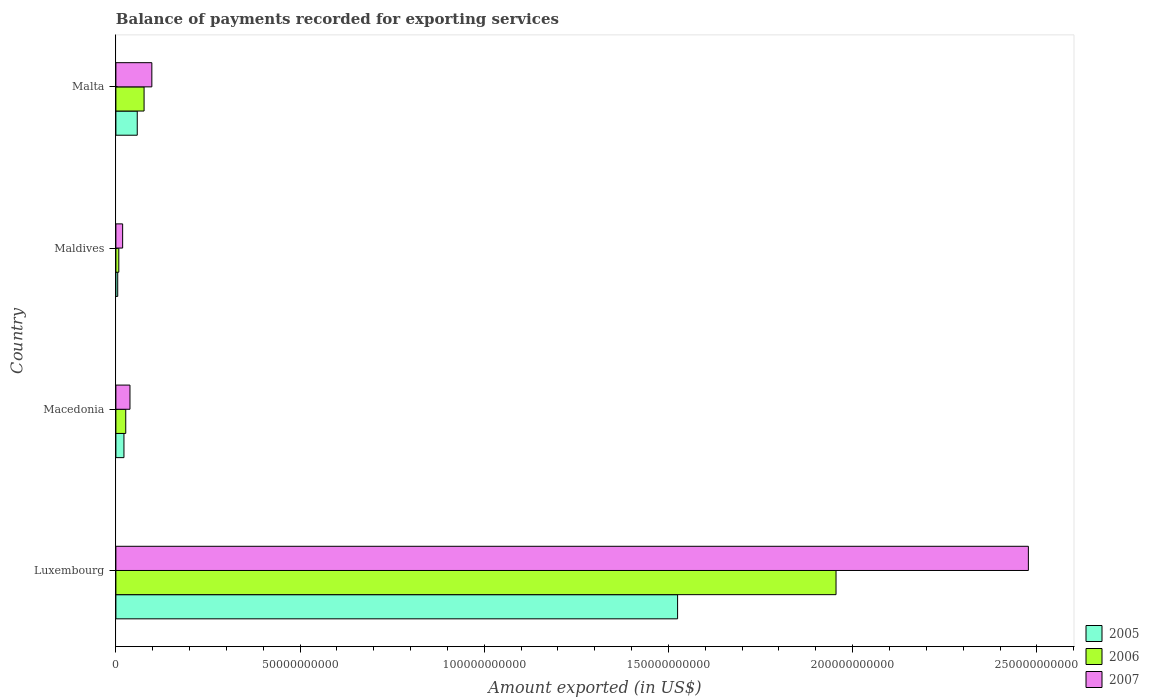How many different coloured bars are there?
Give a very brief answer. 3. How many groups of bars are there?
Offer a very short reply. 4. Are the number of bars per tick equal to the number of legend labels?
Make the answer very short. Yes. Are the number of bars on each tick of the Y-axis equal?
Your answer should be very brief. Yes. How many bars are there on the 4th tick from the bottom?
Give a very brief answer. 3. What is the label of the 4th group of bars from the top?
Your response must be concise. Luxembourg. In how many cases, is the number of bars for a given country not equal to the number of legend labels?
Give a very brief answer. 0. What is the amount exported in 2006 in Maldives?
Your response must be concise. 7.93e+08. Across all countries, what is the maximum amount exported in 2005?
Provide a succinct answer. 1.52e+11. Across all countries, what is the minimum amount exported in 2005?
Your answer should be very brief. 4.95e+08. In which country was the amount exported in 2006 maximum?
Keep it short and to the point. Luxembourg. In which country was the amount exported in 2006 minimum?
Keep it short and to the point. Maldives. What is the total amount exported in 2007 in the graph?
Ensure brevity in your answer.  2.63e+11. What is the difference between the amount exported in 2006 in Luxembourg and that in Maldives?
Provide a succinct answer. 1.95e+11. What is the difference between the amount exported in 2007 in Malta and the amount exported in 2005 in Maldives?
Offer a very short reply. 9.27e+09. What is the average amount exported in 2007 per country?
Offer a very short reply. 6.58e+1. What is the difference between the amount exported in 2006 and amount exported in 2007 in Maldives?
Keep it short and to the point. -1.04e+09. In how many countries, is the amount exported in 2005 greater than 20000000000 US$?
Offer a very short reply. 1. What is the ratio of the amount exported in 2006 in Luxembourg to that in Malta?
Keep it short and to the point. 25.55. What is the difference between the highest and the second highest amount exported in 2006?
Give a very brief answer. 1.88e+11. What is the difference between the highest and the lowest amount exported in 2007?
Give a very brief answer. 2.46e+11. In how many countries, is the amount exported in 2007 greater than the average amount exported in 2007 taken over all countries?
Make the answer very short. 1. What does the 3rd bar from the bottom in Maldives represents?
Your answer should be very brief. 2007. Are all the bars in the graph horizontal?
Your answer should be very brief. Yes. How many countries are there in the graph?
Your answer should be very brief. 4. Does the graph contain any zero values?
Your answer should be very brief. No. Where does the legend appear in the graph?
Provide a succinct answer. Bottom right. How many legend labels are there?
Provide a succinct answer. 3. What is the title of the graph?
Your answer should be very brief. Balance of payments recorded for exporting services. What is the label or title of the X-axis?
Make the answer very short. Amount exported (in US$). What is the Amount exported (in US$) in 2005 in Luxembourg?
Keep it short and to the point. 1.52e+11. What is the Amount exported (in US$) of 2006 in Luxembourg?
Provide a succinct answer. 1.95e+11. What is the Amount exported (in US$) in 2007 in Luxembourg?
Keep it short and to the point. 2.48e+11. What is the Amount exported (in US$) in 2005 in Macedonia?
Your response must be concise. 2.19e+09. What is the Amount exported (in US$) of 2006 in Macedonia?
Your answer should be compact. 2.68e+09. What is the Amount exported (in US$) in 2007 in Macedonia?
Give a very brief answer. 3.82e+09. What is the Amount exported (in US$) in 2005 in Maldives?
Your response must be concise. 4.95e+08. What is the Amount exported (in US$) in 2006 in Maldives?
Offer a terse response. 7.93e+08. What is the Amount exported (in US$) in 2007 in Maldives?
Offer a terse response. 1.83e+09. What is the Amount exported (in US$) in 2005 in Malta?
Give a very brief answer. 5.80e+09. What is the Amount exported (in US$) of 2006 in Malta?
Keep it short and to the point. 7.65e+09. What is the Amount exported (in US$) in 2007 in Malta?
Make the answer very short. 9.76e+09. Across all countries, what is the maximum Amount exported (in US$) in 2005?
Your response must be concise. 1.52e+11. Across all countries, what is the maximum Amount exported (in US$) of 2006?
Your answer should be compact. 1.95e+11. Across all countries, what is the maximum Amount exported (in US$) of 2007?
Your answer should be very brief. 2.48e+11. Across all countries, what is the minimum Amount exported (in US$) of 2005?
Offer a very short reply. 4.95e+08. Across all countries, what is the minimum Amount exported (in US$) of 2006?
Offer a very short reply. 7.93e+08. Across all countries, what is the minimum Amount exported (in US$) of 2007?
Provide a short and direct response. 1.83e+09. What is the total Amount exported (in US$) of 2005 in the graph?
Your answer should be very brief. 1.61e+11. What is the total Amount exported (in US$) of 2006 in the graph?
Offer a terse response. 2.07e+11. What is the total Amount exported (in US$) in 2007 in the graph?
Your answer should be very brief. 2.63e+11. What is the difference between the Amount exported (in US$) of 2005 in Luxembourg and that in Macedonia?
Ensure brevity in your answer.  1.50e+11. What is the difference between the Amount exported (in US$) of 2006 in Luxembourg and that in Macedonia?
Your answer should be compact. 1.93e+11. What is the difference between the Amount exported (in US$) of 2007 in Luxembourg and that in Macedonia?
Provide a short and direct response. 2.44e+11. What is the difference between the Amount exported (in US$) of 2005 in Luxembourg and that in Maldives?
Keep it short and to the point. 1.52e+11. What is the difference between the Amount exported (in US$) of 2006 in Luxembourg and that in Maldives?
Ensure brevity in your answer.  1.95e+11. What is the difference between the Amount exported (in US$) in 2007 in Luxembourg and that in Maldives?
Your response must be concise. 2.46e+11. What is the difference between the Amount exported (in US$) of 2005 in Luxembourg and that in Malta?
Ensure brevity in your answer.  1.47e+11. What is the difference between the Amount exported (in US$) of 2006 in Luxembourg and that in Malta?
Ensure brevity in your answer.  1.88e+11. What is the difference between the Amount exported (in US$) in 2007 in Luxembourg and that in Malta?
Offer a very short reply. 2.38e+11. What is the difference between the Amount exported (in US$) of 2005 in Macedonia and that in Maldives?
Provide a succinct answer. 1.69e+09. What is the difference between the Amount exported (in US$) of 2006 in Macedonia and that in Maldives?
Provide a short and direct response. 1.89e+09. What is the difference between the Amount exported (in US$) in 2007 in Macedonia and that in Maldives?
Your response must be concise. 1.99e+09. What is the difference between the Amount exported (in US$) of 2005 in Macedonia and that in Malta?
Offer a terse response. -3.61e+09. What is the difference between the Amount exported (in US$) in 2006 in Macedonia and that in Malta?
Offer a terse response. -4.97e+09. What is the difference between the Amount exported (in US$) of 2007 in Macedonia and that in Malta?
Your answer should be compact. -5.94e+09. What is the difference between the Amount exported (in US$) in 2005 in Maldives and that in Malta?
Offer a very short reply. -5.30e+09. What is the difference between the Amount exported (in US$) of 2006 in Maldives and that in Malta?
Offer a very short reply. -6.86e+09. What is the difference between the Amount exported (in US$) in 2007 in Maldives and that in Malta?
Ensure brevity in your answer.  -7.93e+09. What is the difference between the Amount exported (in US$) of 2005 in Luxembourg and the Amount exported (in US$) of 2006 in Macedonia?
Provide a short and direct response. 1.50e+11. What is the difference between the Amount exported (in US$) in 2005 in Luxembourg and the Amount exported (in US$) in 2007 in Macedonia?
Provide a succinct answer. 1.49e+11. What is the difference between the Amount exported (in US$) of 2006 in Luxembourg and the Amount exported (in US$) of 2007 in Macedonia?
Ensure brevity in your answer.  1.92e+11. What is the difference between the Amount exported (in US$) of 2005 in Luxembourg and the Amount exported (in US$) of 2006 in Maldives?
Offer a very short reply. 1.52e+11. What is the difference between the Amount exported (in US$) of 2005 in Luxembourg and the Amount exported (in US$) of 2007 in Maldives?
Offer a terse response. 1.51e+11. What is the difference between the Amount exported (in US$) in 2006 in Luxembourg and the Amount exported (in US$) in 2007 in Maldives?
Offer a terse response. 1.94e+11. What is the difference between the Amount exported (in US$) in 2005 in Luxembourg and the Amount exported (in US$) in 2006 in Malta?
Offer a terse response. 1.45e+11. What is the difference between the Amount exported (in US$) of 2005 in Luxembourg and the Amount exported (in US$) of 2007 in Malta?
Provide a short and direct response. 1.43e+11. What is the difference between the Amount exported (in US$) in 2006 in Luxembourg and the Amount exported (in US$) in 2007 in Malta?
Offer a very short reply. 1.86e+11. What is the difference between the Amount exported (in US$) in 2005 in Macedonia and the Amount exported (in US$) in 2006 in Maldives?
Provide a succinct answer. 1.40e+09. What is the difference between the Amount exported (in US$) of 2005 in Macedonia and the Amount exported (in US$) of 2007 in Maldives?
Ensure brevity in your answer.  3.59e+08. What is the difference between the Amount exported (in US$) of 2006 in Macedonia and the Amount exported (in US$) of 2007 in Maldives?
Provide a short and direct response. 8.48e+08. What is the difference between the Amount exported (in US$) of 2005 in Macedonia and the Amount exported (in US$) of 2006 in Malta?
Ensure brevity in your answer.  -5.46e+09. What is the difference between the Amount exported (in US$) in 2005 in Macedonia and the Amount exported (in US$) in 2007 in Malta?
Give a very brief answer. -7.57e+09. What is the difference between the Amount exported (in US$) in 2006 in Macedonia and the Amount exported (in US$) in 2007 in Malta?
Make the answer very short. -7.08e+09. What is the difference between the Amount exported (in US$) of 2005 in Maldives and the Amount exported (in US$) of 2006 in Malta?
Keep it short and to the point. -7.16e+09. What is the difference between the Amount exported (in US$) of 2005 in Maldives and the Amount exported (in US$) of 2007 in Malta?
Make the answer very short. -9.27e+09. What is the difference between the Amount exported (in US$) of 2006 in Maldives and the Amount exported (in US$) of 2007 in Malta?
Keep it short and to the point. -8.97e+09. What is the average Amount exported (in US$) of 2005 per country?
Offer a terse response. 4.02e+1. What is the average Amount exported (in US$) in 2006 per country?
Provide a succinct answer. 5.17e+1. What is the average Amount exported (in US$) of 2007 per country?
Provide a succinct answer. 6.58e+1. What is the difference between the Amount exported (in US$) of 2005 and Amount exported (in US$) of 2006 in Luxembourg?
Make the answer very short. -4.30e+1. What is the difference between the Amount exported (in US$) in 2005 and Amount exported (in US$) in 2007 in Luxembourg?
Your answer should be compact. -9.52e+1. What is the difference between the Amount exported (in US$) of 2006 and Amount exported (in US$) of 2007 in Luxembourg?
Your answer should be compact. -5.22e+1. What is the difference between the Amount exported (in US$) in 2005 and Amount exported (in US$) in 2006 in Macedonia?
Your answer should be compact. -4.89e+08. What is the difference between the Amount exported (in US$) of 2005 and Amount exported (in US$) of 2007 in Macedonia?
Your answer should be very brief. -1.63e+09. What is the difference between the Amount exported (in US$) in 2006 and Amount exported (in US$) in 2007 in Macedonia?
Provide a succinct answer. -1.14e+09. What is the difference between the Amount exported (in US$) in 2005 and Amount exported (in US$) in 2006 in Maldives?
Your answer should be compact. -2.97e+08. What is the difference between the Amount exported (in US$) in 2005 and Amount exported (in US$) in 2007 in Maldives?
Your response must be concise. -1.34e+09. What is the difference between the Amount exported (in US$) in 2006 and Amount exported (in US$) in 2007 in Maldives?
Offer a terse response. -1.04e+09. What is the difference between the Amount exported (in US$) of 2005 and Amount exported (in US$) of 2006 in Malta?
Give a very brief answer. -1.85e+09. What is the difference between the Amount exported (in US$) of 2005 and Amount exported (in US$) of 2007 in Malta?
Keep it short and to the point. -3.96e+09. What is the difference between the Amount exported (in US$) in 2006 and Amount exported (in US$) in 2007 in Malta?
Provide a short and direct response. -2.11e+09. What is the ratio of the Amount exported (in US$) in 2005 in Luxembourg to that in Macedonia?
Make the answer very short. 69.63. What is the ratio of the Amount exported (in US$) in 2006 in Luxembourg to that in Macedonia?
Give a very brief answer. 72.98. What is the ratio of the Amount exported (in US$) in 2007 in Luxembourg to that in Macedonia?
Ensure brevity in your answer.  64.83. What is the ratio of the Amount exported (in US$) in 2005 in Luxembourg to that in Maldives?
Offer a terse response. 307.8. What is the ratio of the Amount exported (in US$) of 2006 in Luxembourg to that in Maldives?
Ensure brevity in your answer.  246.61. What is the ratio of the Amount exported (in US$) in 2007 in Luxembourg to that in Maldives?
Provide a succinct answer. 135.31. What is the ratio of the Amount exported (in US$) in 2005 in Luxembourg to that in Malta?
Make the answer very short. 26.29. What is the ratio of the Amount exported (in US$) of 2006 in Luxembourg to that in Malta?
Provide a short and direct response. 25.55. What is the ratio of the Amount exported (in US$) of 2007 in Luxembourg to that in Malta?
Ensure brevity in your answer.  25.38. What is the ratio of the Amount exported (in US$) in 2005 in Macedonia to that in Maldives?
Ensure brevity in your answer.  4.42. What is the ratio of the Amount exported (in US$) of 2006 in Macedonia to that in Maldives?
Your answer should be compact. 3.38. What is the ratio of the Amount exported (in US$) of 2007 in Macedonia to that in Maldives?
Provide a succinct answer. 2.09. What is the ratio of the Amount exported (in US$) of 2005 in Macedonia to that in Malta?
Give a very brief answer. 0.38. What is the ratio of the Amount exported (in US$) of 2006 in Macedonia to that in Malta?
Give a very brief answer. 0.35. What is the ratio of the Amount exported (in US$) in 2007 in Macedonia to that in Malta?
Offer a terse response. 0.39. What is the ratio of the Amount exported (in US$) in 2005 in Maldives to that in Malta?
Keep it short and to the point. 0.09. What is the ratio of the Amount exported (in US$) in 2006 in Maldives to that in Malta?
Keep it short and to the point. 0.1. What is the ratio of the Amount exported (in US$) of 2007 in Maldives to that in Malta?
Your answer should be compact. 0.19. What is the difference between the highest and the second highest Amount exported (in US$) in 2005?
Keep it short and to the point. 1.47e+11. What is the difference between the highest and the second highest Amount exported (in US$) of 2006?
Give a very brief answer. 1.88e+11. What is the difference between the highest and the second highest Amount exported (in US$) of 2007?
Ensure brevity in your answer.  2.38e+11. What is the difference between the highest and the lowest Amount exported (in US$) in 2005?
Offer a terse response. 1.52e+11. What is the difference between the highest and the lowest Amount exported (in US$) in 2006?
Ensure brevity in your answer.  1.95e+11. What is the difference between the highest and the lowest Amount exported (in US$) of 2007?
Give a very brief answer. 2.46e+11. 